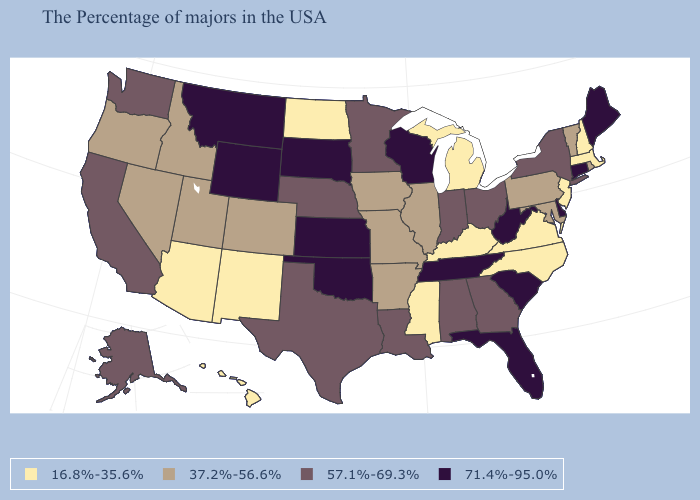What is the lowest value in the USA?
Be succinct. 16.8%-35.6%. Which states have the lowest value in the USA?
Quick response, please. Massachusetts, New Hampshire, New Jersey, Virginia, North Carolina, Michigan, Kentucky, Mississippi, North Dakota, New Mexico, Arizona, Hawaii. Does New Jersey have the lowest value in the Northeast?
Quick response, please. Yes. How many symbols are there in the legend?
Answer briefly. 4. Name the states that have a value in the range 57.1%-69.3%?
Short answer required. New York, Ohio, Georgia, Indiana, Alabama, Louisiana, Minnesota, Nebraska, Texas, California, Washington, Alaska. What is the value of New Hampshire?
Answer briefly. 16.8%-35.6%. What is the value of New Jersey?
Quick response, please. 16.8%-35.6%. Which states have the highest value in the USA?
Give a very brief answer. Maine, Connecticut, Delaware, South Carolina, West Virginia, Florida, Tennessee, Wisconsin, Kansas, Oklahoma, South Dakota, Wyoming, Montana. Does Mississippi have the lowest value in the USA?
Keep it brief. Yes. Name the states that have a value in the range 57.1%-69.3%?
Be succinct. New York, Ohio, Georgia, Indiana, Alabama, Louisiana, Minnesota, Nebraska, Texas, California, Washington, Alaska. Does the first symbol in the legend represent the smallest category?
Be succinct. Yes. What is the value of Pennsylvania?
Write a very short answer. 37.2%-56.6%. What is the value of Arizona?
Quick response, please. 16.8%-35.6%. Does Alabama have the lowest value in the USA?
Give a very brief answer. No. Name the states that have a value in the range 71.4%-95.0%?
Short answer required. Maine, Connecticut, Delaware, South Carolina, West Virginia, Florida, Tennessee, Wisconsin, Kansas, Oklahoma, South Dakota, Wyoming, Montana. 